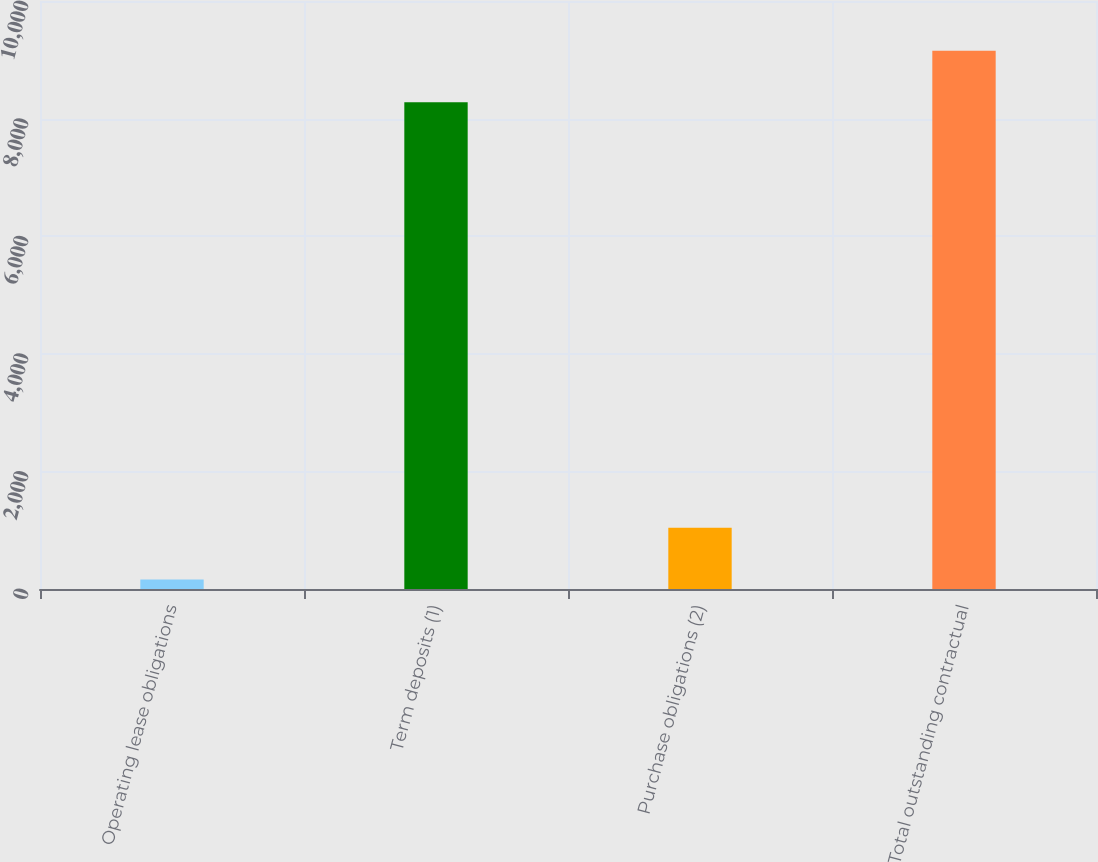Convert chart. <chart><loc_0><loc_0><loc_500><loc_500><bar_chart><fcel>Operating lease obligations<fcel>Term deposits (1)<fcel>Purchase obligations (2)<fcel>Total outstanding contractual<nl><fcel>162<fcel>8278<fcel>1039.9<fcel>9155.9<nl></chart> 